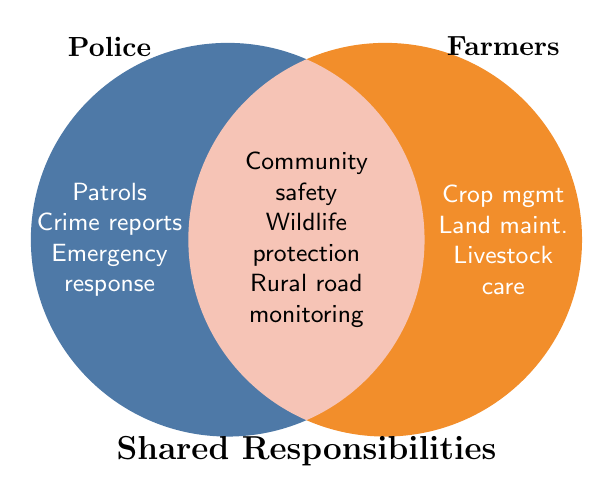what is the main responsibility listed for farmers? The responsibilities listed for farmers include crop management, land maintenance, livestock care, pest control, irrigation management, harvest schedules, soil conservation, and equipment maintenance.
Answer: Crop management Which shared responsibilities are related to the environment? The shared responsibilities related to the environment listed are wildlife protection, environmental vandalism detection, and fire prevention. By scanning the shared segment of the Venn Diagram, these tasks can be identified.
Answer: Wildlife protection, environmental vandalism detection, fire prevention Name one responsibility exclusive to the police. Reviewing the police section of the Venn Diagram, some of their exclusive responsibilities are patrols, crime reports, emergency response, traffic control, evidence collection, arrests, interrogations, and crowd control.
Answer: Patrols Identify one task both police and farmers are involved in for community safety. Within the shared responsibilities section of the Venn Diagram, one of the tasks listed is community safety, which both farmers and police are involved in.
Answer: Community safety How many exclusive responsibilities do farmers have as listed in the figure? Looking at the responsibilities under the farmer's section of the Venn Diagram, there are eight (crop management, land maintenance, livestock care, pest control, irrigation management, harvest schedules, soil conservation, equipment maintenance).
Answer: Eight Which area has more listed responsibilities, police or shared? By counting the elements in the police section (8) and shared section (8), the number of responsibilities is equal for both areas.
Answer: Equal Name a shared responsibility that helps in emergency situations. In the shared section of the Venn Diagram, disaster preparedness is listed, which directly helps in emergency situations.
Answer: Disaster preparedness What is a common task for both farmers and police in maintaining safety? In the shared section of the Venn Diagram, trespassing prevention is one of the listed tasks relating to maintaining safety for both farmers and police.
Answer: Trespassing prevention Which responsibility is shared that also involves reporting? In the shared responsibilities section of the Venn Diagram, suspicious activity reporting involves reporting.
Answer: Suspicious activity reporting 